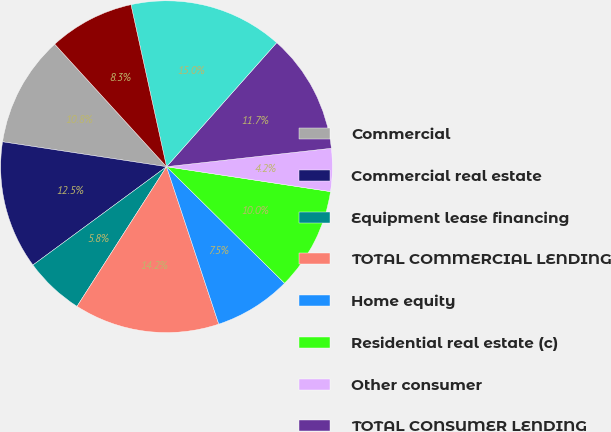Convert chart. <chart><loc_0><loc_0><loc_500><loc_500><pie_chart><fcel>Commercial<fcel>Commercial real estate<fcel>Equipment lease financing<fcel>TOTAL COMMERCIAL LENDING<fcel>Home equity<fcel>Residential real estate (c)<fcel>Other consumer<fcel>TOTAL CONSUMER LENDING<fcel>Total nonperforming loans (e)<fcel>Other real estate owned (OREO)<nl><fcel>10.83%<fcel>12.5%<fcel>5.83%<fcel>14.17%<fcel>7.5%<fcel>10.0%<fcel>4.17%<fcel>11.67%<fcel>15.0%<fcel>8.33%<nl></chart> 